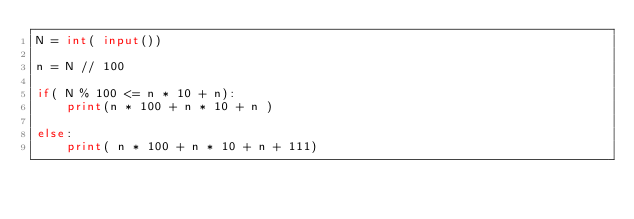<code> <loc_0><loc_0><loc_500><loc_500><_Python_>N = int( input())
 
n = N // 100
 
if( N % 100 <= n * 10 + n):
	print(n * 100 + n * 10 + n )
  
else:
  	print( n * 100 + n * 10 + n + 111)</code> 